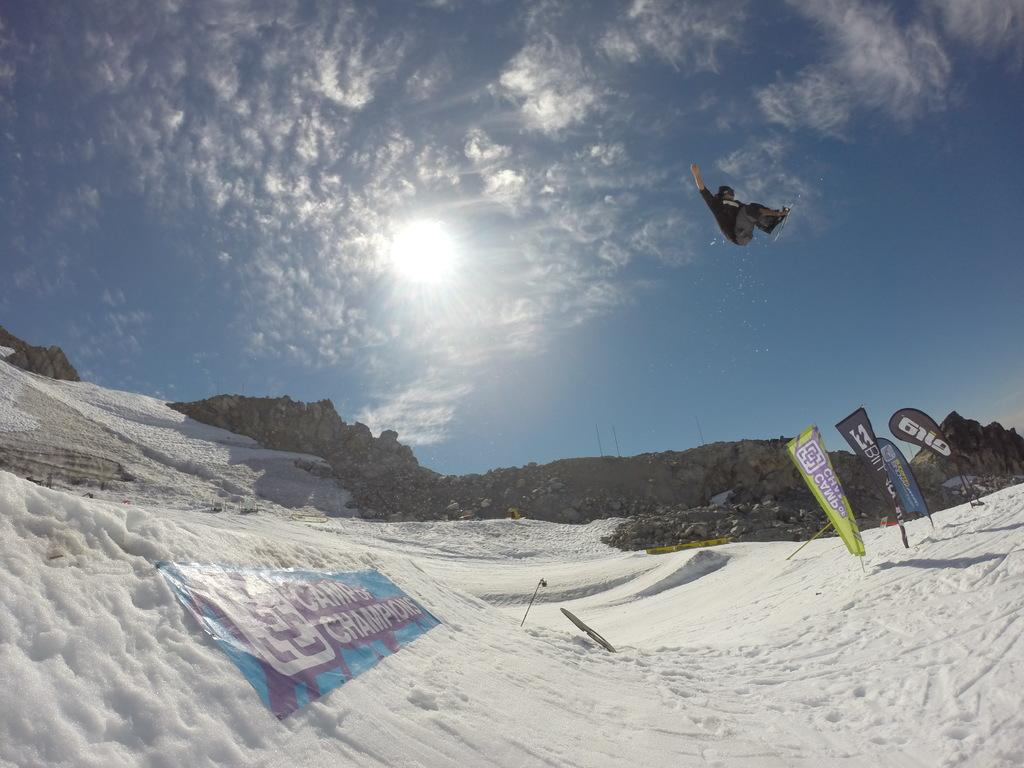What is the weather like in the image? There is snow in the image, indicating a cold and likely wintery environment. What type of landscape can be seen in the image? There are mountains in the image, suggesting a mountainous or hilly terrain. What is visible in the sky in the image? There are clouds visible in the sky. How many lizards can be seen basking in the snow in the image? There are no lizards present in the image; the focus is on the snow and mountains. What type of giants inhabit the mountains in the image? There is no mention of giants or any other creatures in the image; it primarily features snow and mountains. 